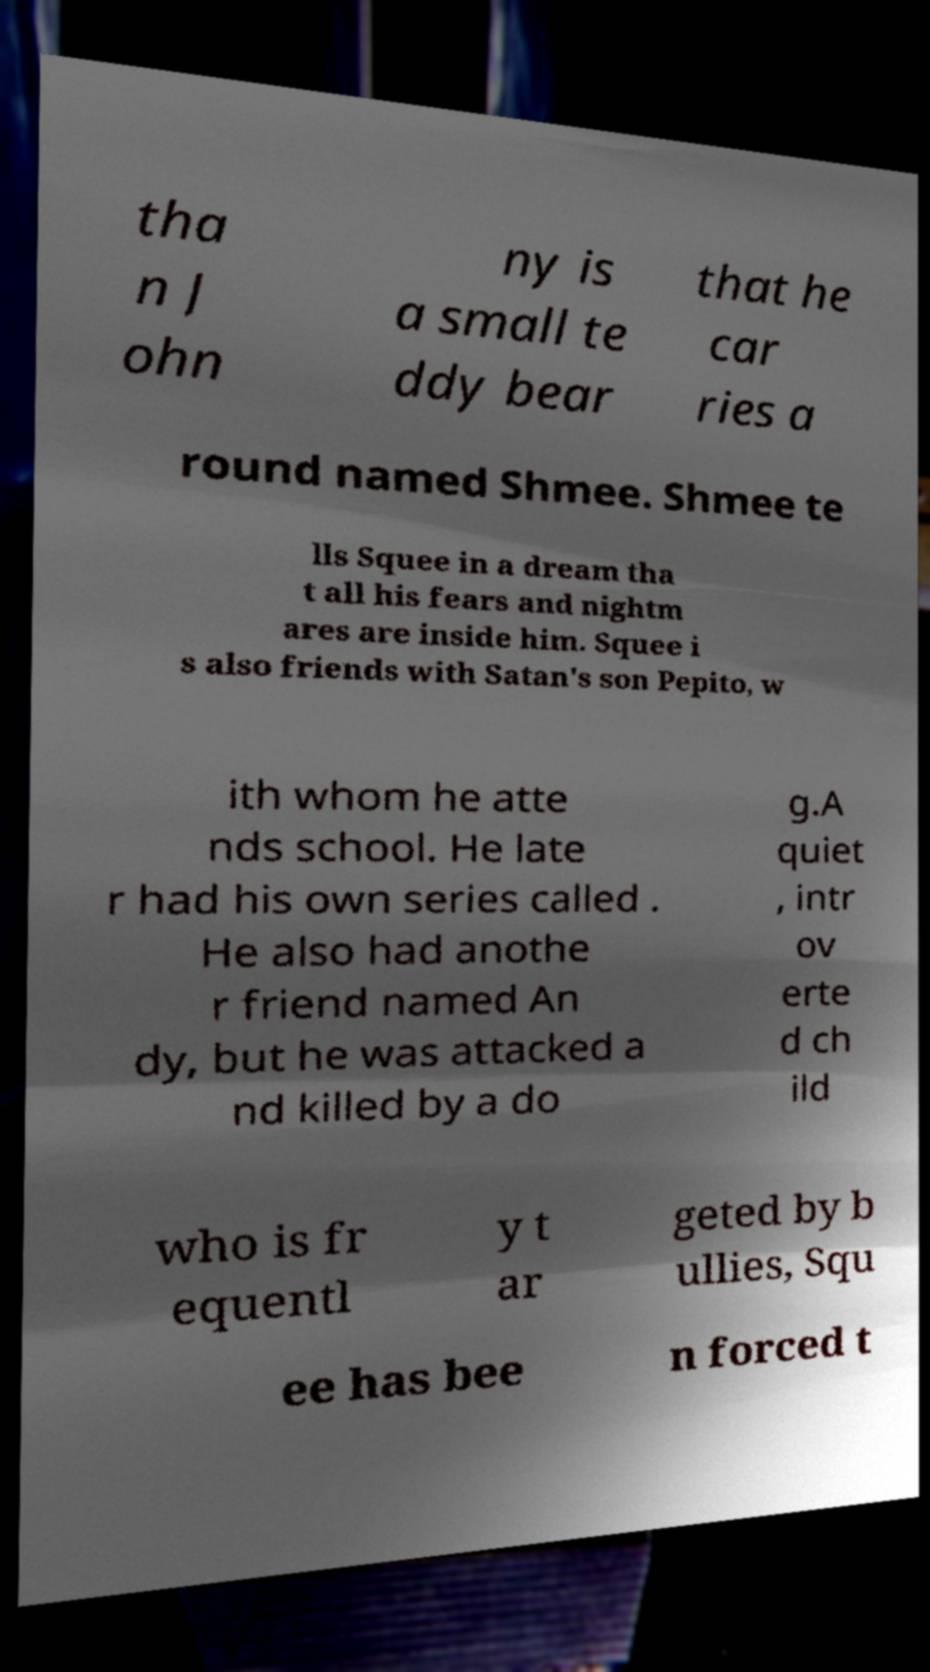Could you extract and type out the text from this image? tha n J ohn ny is a small te ddy bear that he car ries a round named Shmee. Shmee te lls Squee in a dream tha t all his fears and nightm ares are inside him. Squee i s also friends with Satan's son Pepito, w ith whom he atte nds school. He late r had his own series called . He also had anothe r friend named An dy, but he was attacked a nd killed by a do g.A quiet , intr ov erte d ch ild who is fr equentl y t ar geted by b ullies, Squ ee has bee n forced t 